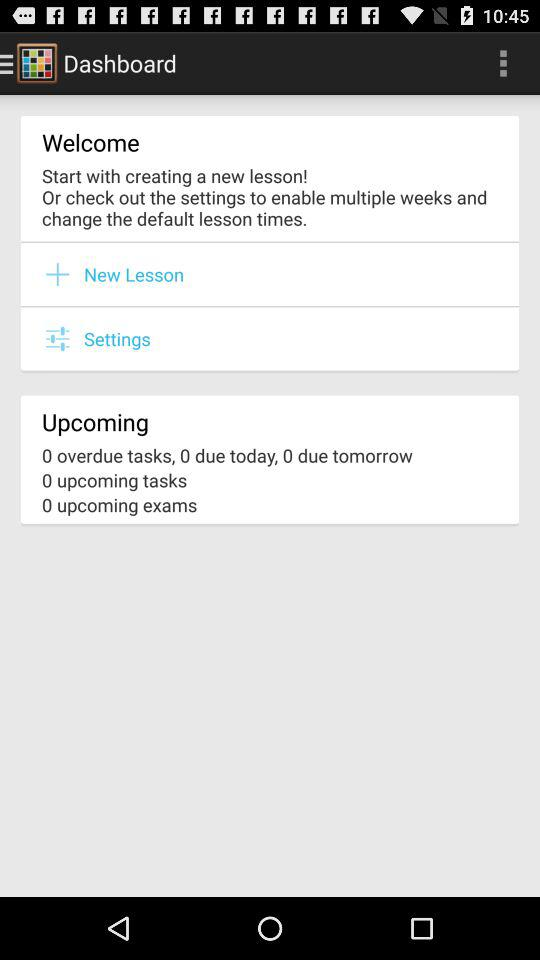Are there any overdue tasks? There are no overdue tasks. 